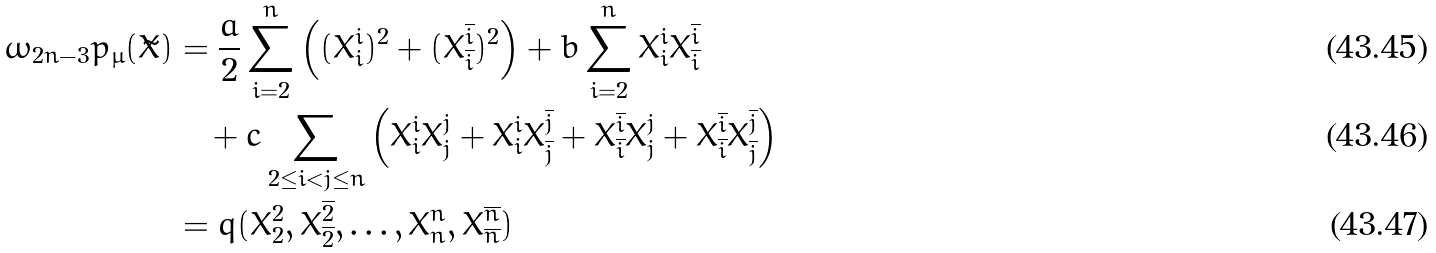<formula> <loc_0><loc_0><loc_500><loc_500>\omega _ { 2 n - 3 } p _ { \mu } ( \tilde { X } ) & = \frac { a } { 2 } \sum _ { i = 2 } ^ { n } \left ( ( X ^ { i } _ { i } ) ^ { 2 } + ( X ^ { \overline { i } } _ { \overline { i } } ) ^ { 2 } \right ) + b \sum _ { i = 2 } ^ { n } X ^ { i } _ { i } X ^ { \overline { i } } _ { \overline { i } } \\ & \quad + c \sum _ { 2 \leq i < j \leq n } \left ( X ^ { i } _ { i } X ^ { j } _ { j } + X ^ { i } _ { i } X ^ { \overline { j } } _ { \overline { j } } + X ^ { \overline { i } } _ { \overline { i } } X ^ { j } _ { j } + X ^ { \overline { i } } _ { \overline { i } } X ^ { \overline { j } } _ { \overline { j } } \right ) \\ & = q ( X _ { 2 } ^ { 2 } , X _ { \overline { 2 } } ^ { \overline { 2 } } , \dots , X _ { n } ^ { n } , X _ { \overline { n } } ^ { \overline { n } } )</formula> 